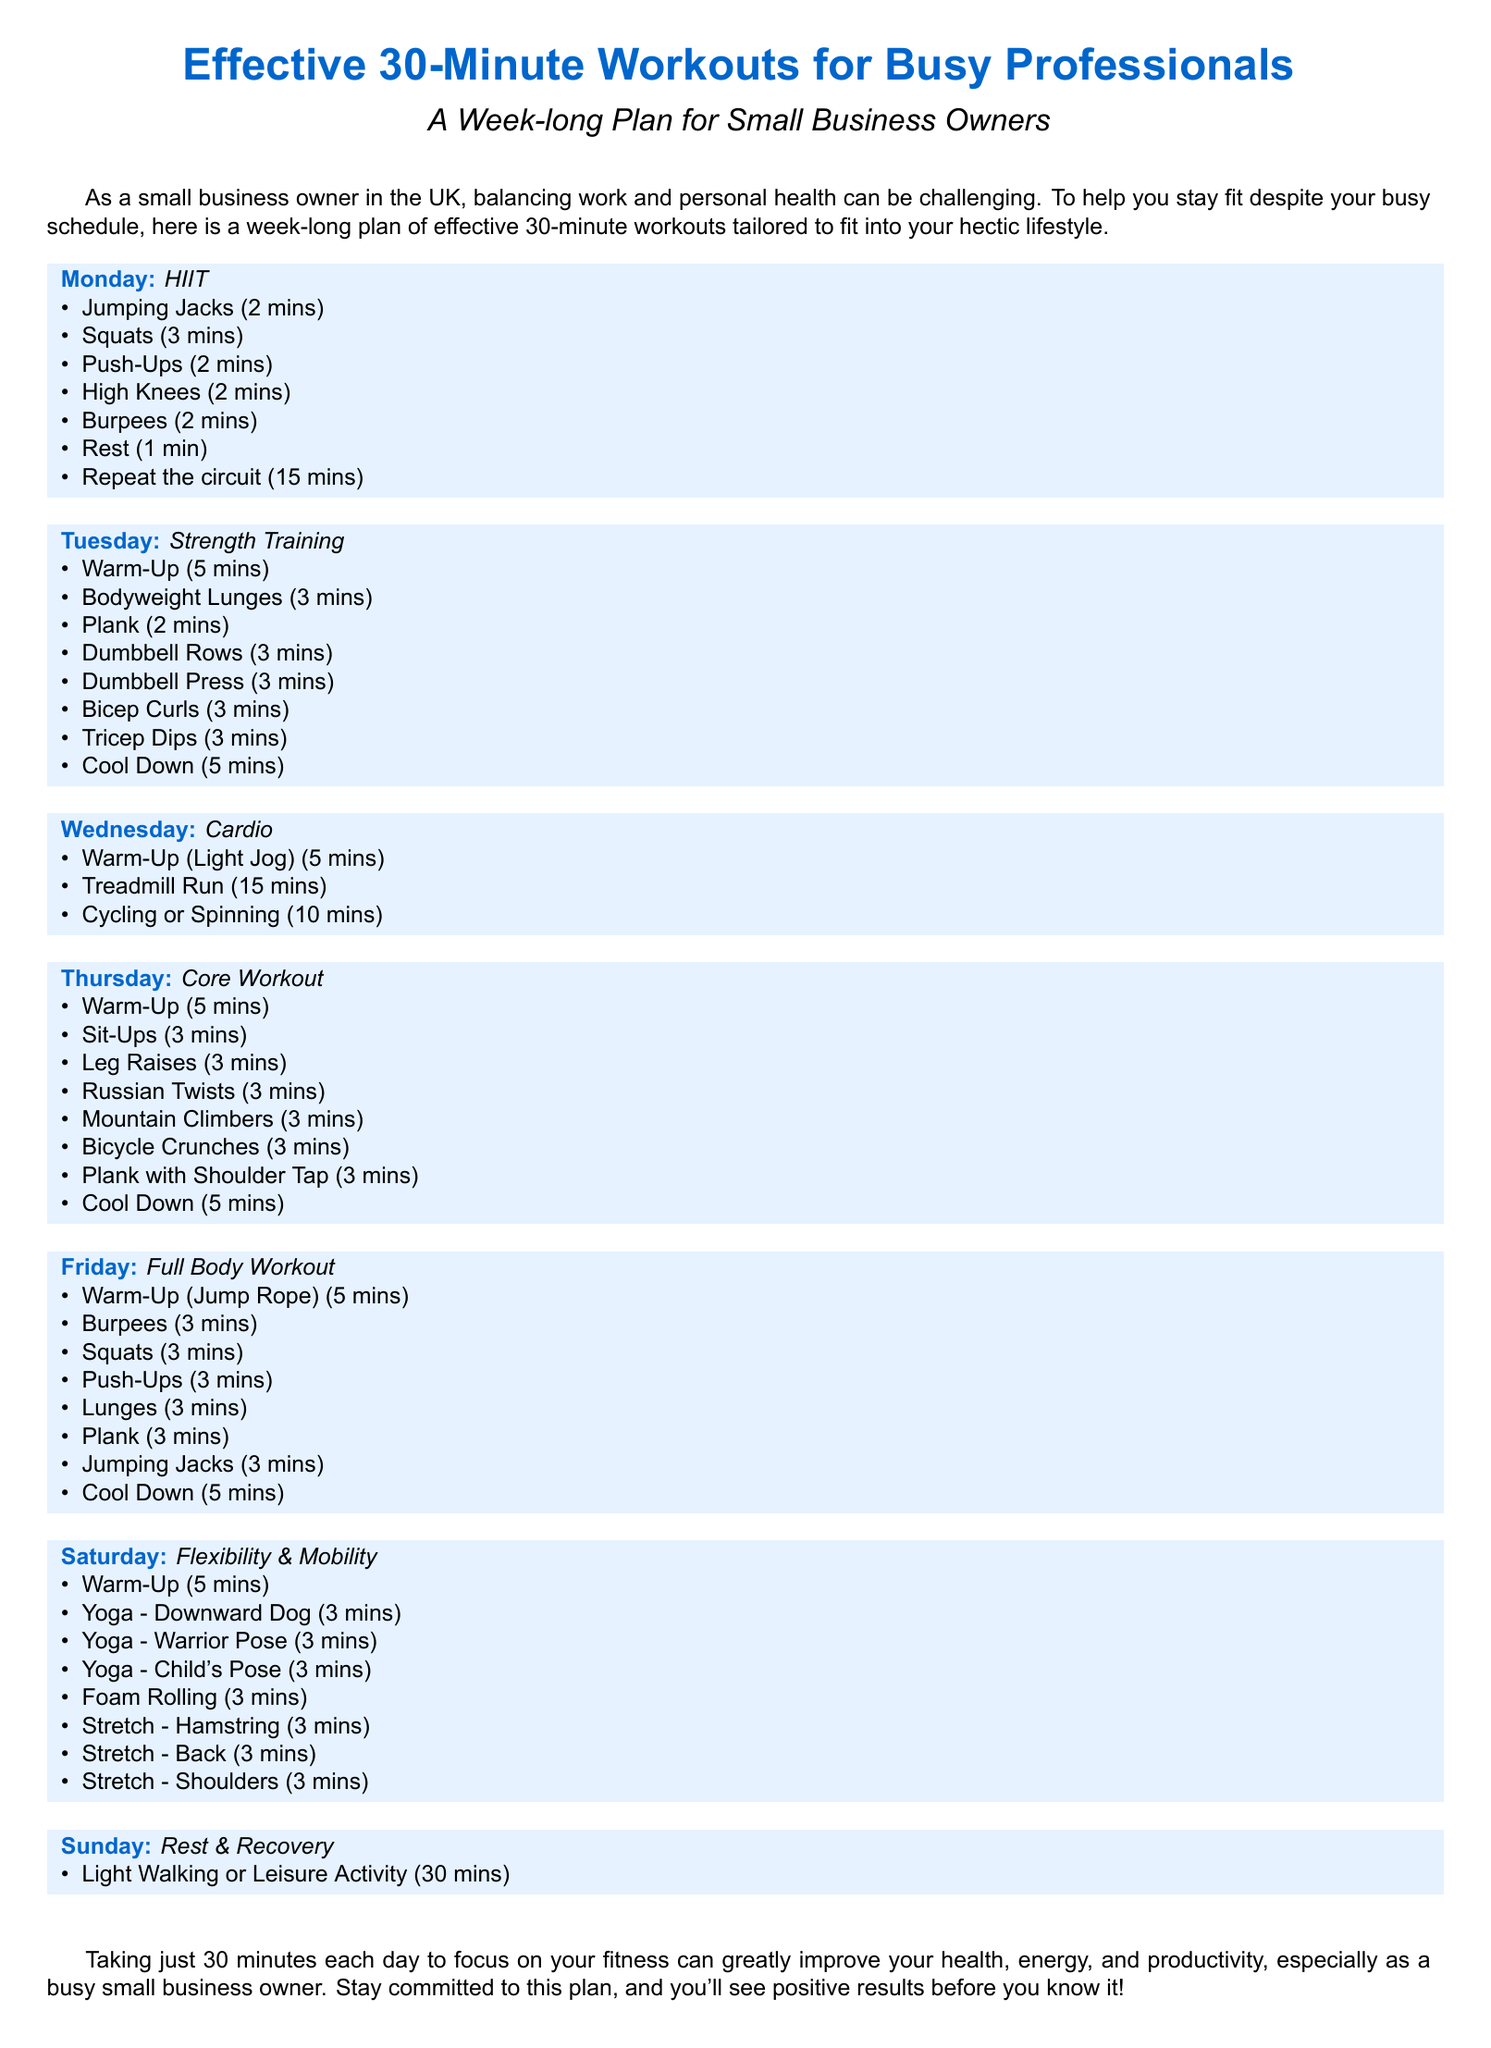what is the total duration of each workout? Each workout is designed to be completed in 30 minutes.
Answer: 30 minutes how many exercises are listed for Monday's workout? The Monday HIIT workout includes 7 exercises.
Answer: 7 exercises what type of workout is scheduled for Wednesday? The workout for Wednesday is categorized as Cardio.
Answer: Cardio how long should the Light Walking or Leisure Activity be on Sunday? The recommended duration for Sunday’s activity is 30 minutes.
Answer: 30 minutes which muscle group is targeted on Tuesday? Tuesday's workout focuses on Strength Training exercises.
Answer: Strength Training what is the main focus of Saturday's workout? Saturday's session is concentrated on Flexibility & Mobility.
Answer: Flexibility & Mobility how many minutes are allocated for Cool Down on Friday? The Cool Down on Friday is allocated 5 minutes.
Answer: 5 minutes which exercise is included in both Monday and Friday workouts? Burpees are included in both Monday and Friday workouts.
Answer: Burpees how long is the Warm-Up for the Core Workout on Thursday? The Warm-Up for Thursday's Core Workout is 5 minutes.
Answer: 5 minutes 